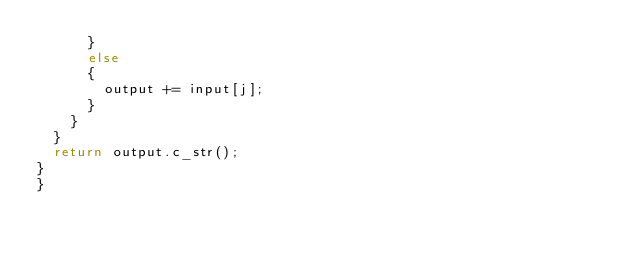Convert code to text. <code><loc_0><loc_0><loc_500><loc_500><_C++_>			}
			else
			{
				output += input[j];
			}
		}
	}
	return output.c_str();
}
}
</code> 